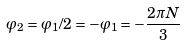Convert formula to latex. <formula><loc_0><loc_0><loc_500><loc_500>\varphi _ { 2 } = \varphi _ { 1 } / 2 = - \varphi _ { 1 } = - \frac { 2 \pi N } { 3 }</formula> 